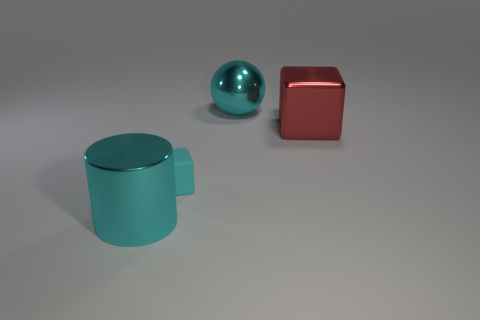Add 1 large metallic blocks. How many objects exist? 5 Subtract all spheres. How many objects are left? 3 Add 4 tiny cyan shiny balls. How many tiny cyan shiny balls exist? 4 Subtract 0 green blocks. How many objects are left? 4 Subtract all big red things. Subtract all small rubber blocks. How many objects are left? 2 Add 1 big metal cylinders. How many big metal cylinders are left? 2 